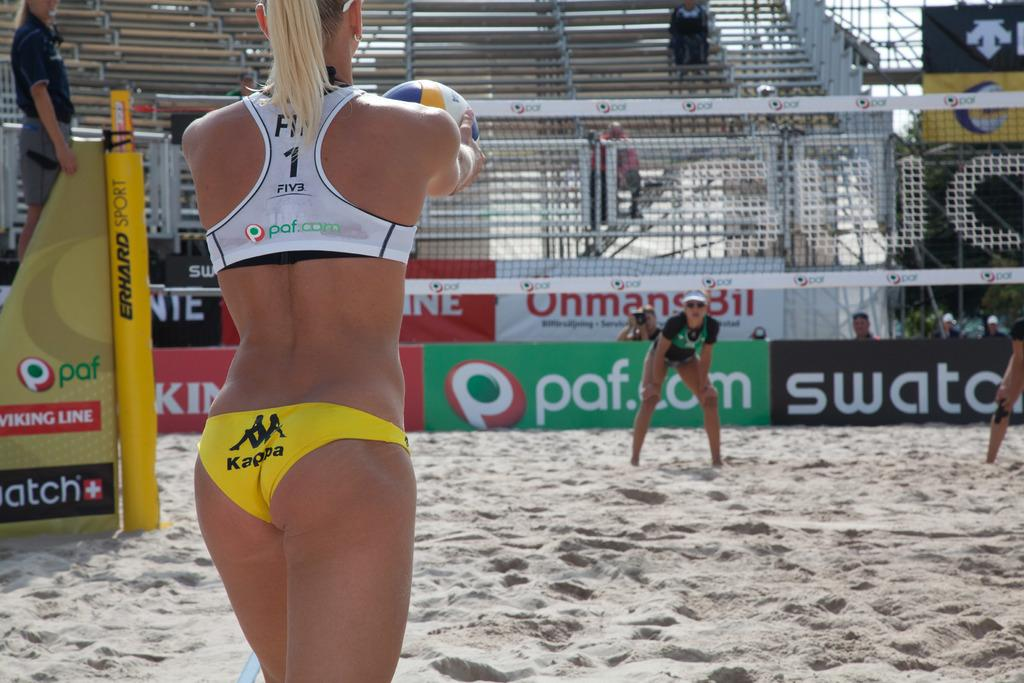<image>
Offer a succinct explanation of the picture presented. A woman playing volleyball wearing yellow Kappa bottoms and white Paf top. 